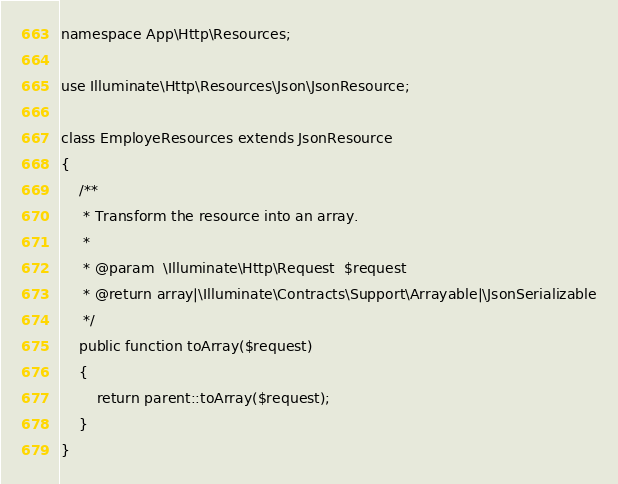<code> <loc_0><loc_0><loc_500><loc_500><_PHP_>
namespace App\Http\Resources;

use Illuminate\Http\Resources\Json\JsonResource;

class EmployeResources extends JsonResource
{
    /**
     * Transform the resource into an array.
     *
     * @param  \Illuminate\Http\Request  $request
     * @return array|\Illuminate\Contracts\Support\Arrayable|\JsonSerializable
     */
    public function toArray($request)
    {
        return parent::toArray($request);
    }
}
</code> 